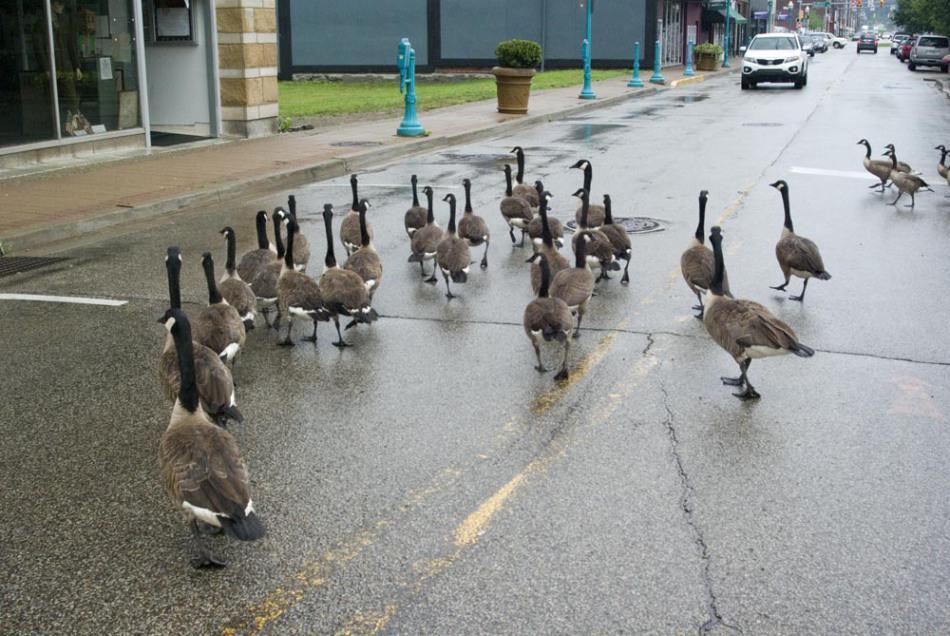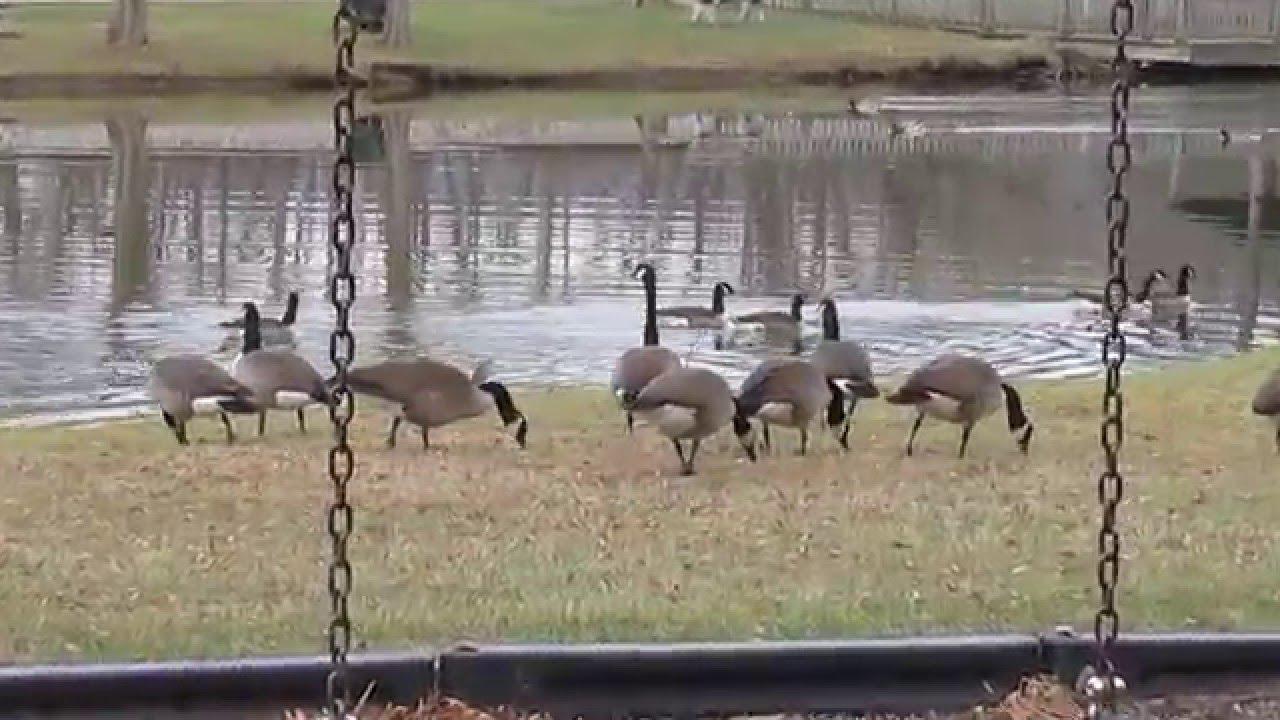The first image is the image on the left, the second image is the image on the right. Analyze the images presented: Is the assertion "A flock of birds are walking on a paved paint-striped road in one image." valid? Answer yes or no. Yes. The first image is the image on the left, the second image is the image on the right. Evaluate the accuracy of this statement regarding the images: "Neither of the images of geese contains a human standing on the ground.". Is it true? Answer yes or no. Yes. 